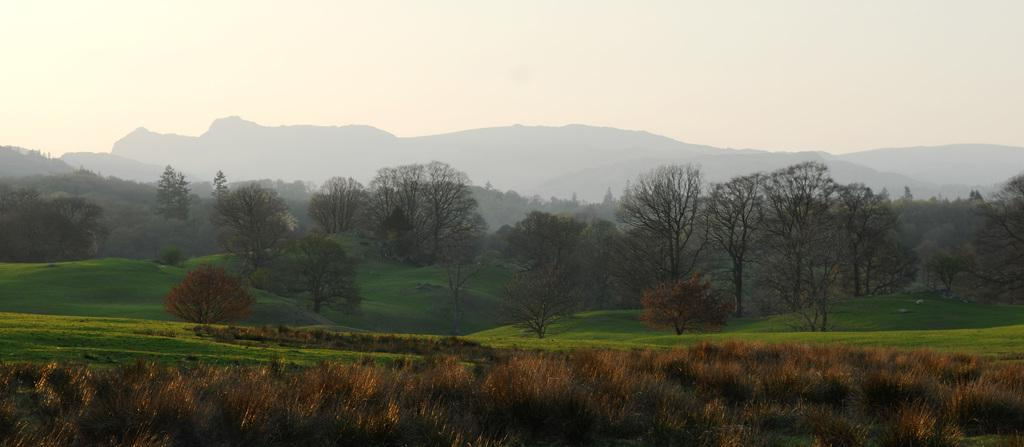What type of vegetation can be seen in the image? There is grass in the image. What other natural elements are present in the image? There are trees and mountains in the image. What can be seen in the background of the image? The sky is visible in the background of the image. What type of seed is being used to start the engine in the image? There is no engine or seed present in the image; it features grass, trees, mountains, and the sky. How can you help the trees in the image grow taller? The image does not require any assistance for the trees to grow taller, as it is a static representation of the scene. 